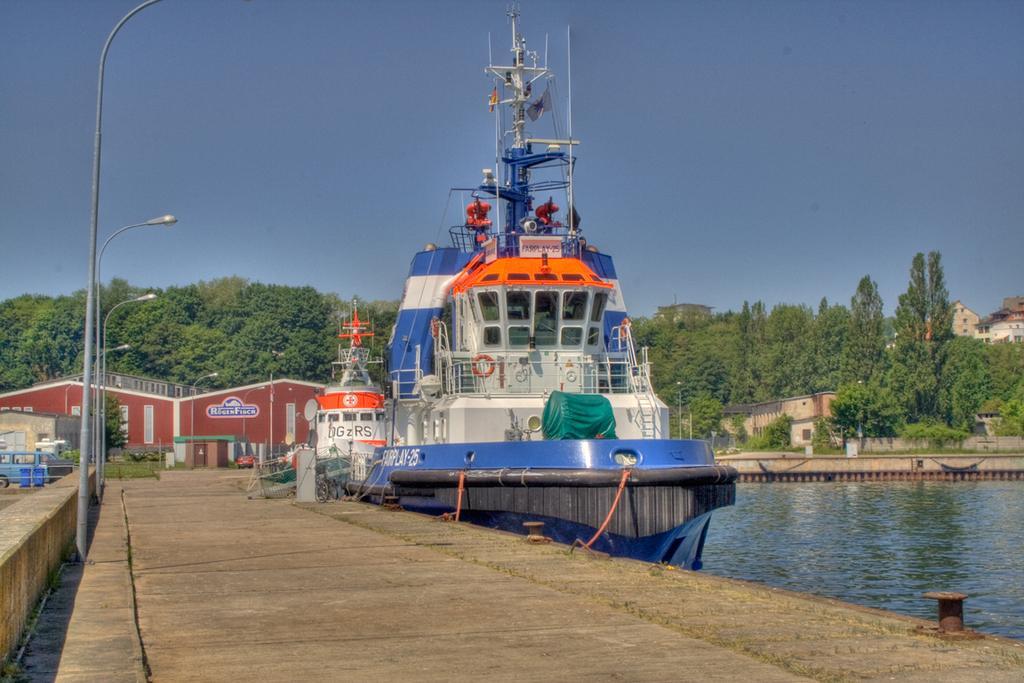How would you summarize this image in a sentence or two? This picture shows boats in the water and we see buildings and a car parked and we see trees and few pole lights and a blue sky. 